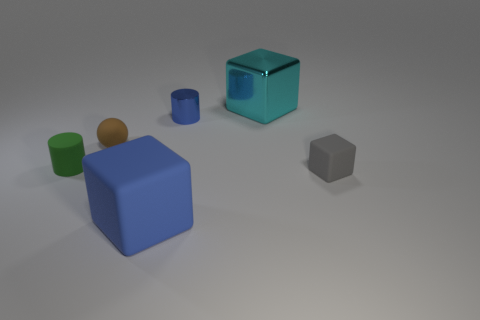What is the material of the large object that is the same color as the shiny cylinder?
Provide a succinct answer. Rubber. What number of other things are the same shape as the big cyan metal object?
Keep it short and to the point. 2. There is a large block that is in front of the cylinder that is right of the big block that is in front of the tiny cube; what color is it?
Provide a succinct answer. Blue. How many matte objects are there?
Make the answer very short. 4. What number of tiny things are green rubber objects or rubber objects?
Offer a terse response. 3. What shape is the green matte object that is the same size as the blue shiny cylinder?
Provide a succinct answer. Cylinder. What material is the small cylinder to the right of the big block that is in front of the small blue metal thing?
Offer a terse response. Metal. Is the brown object the same size as the gray matte object?
Ensure brevity in your answer.  Yes. What number of things are large blocks behind the brown sphere or yellow metal blocks?
Give a very brief answer. 1. What is the shape of the shiny thing that is in front of the large block that is to the right of the tiny blue cylinder?
Provide a short and direct response. Cylinder. 